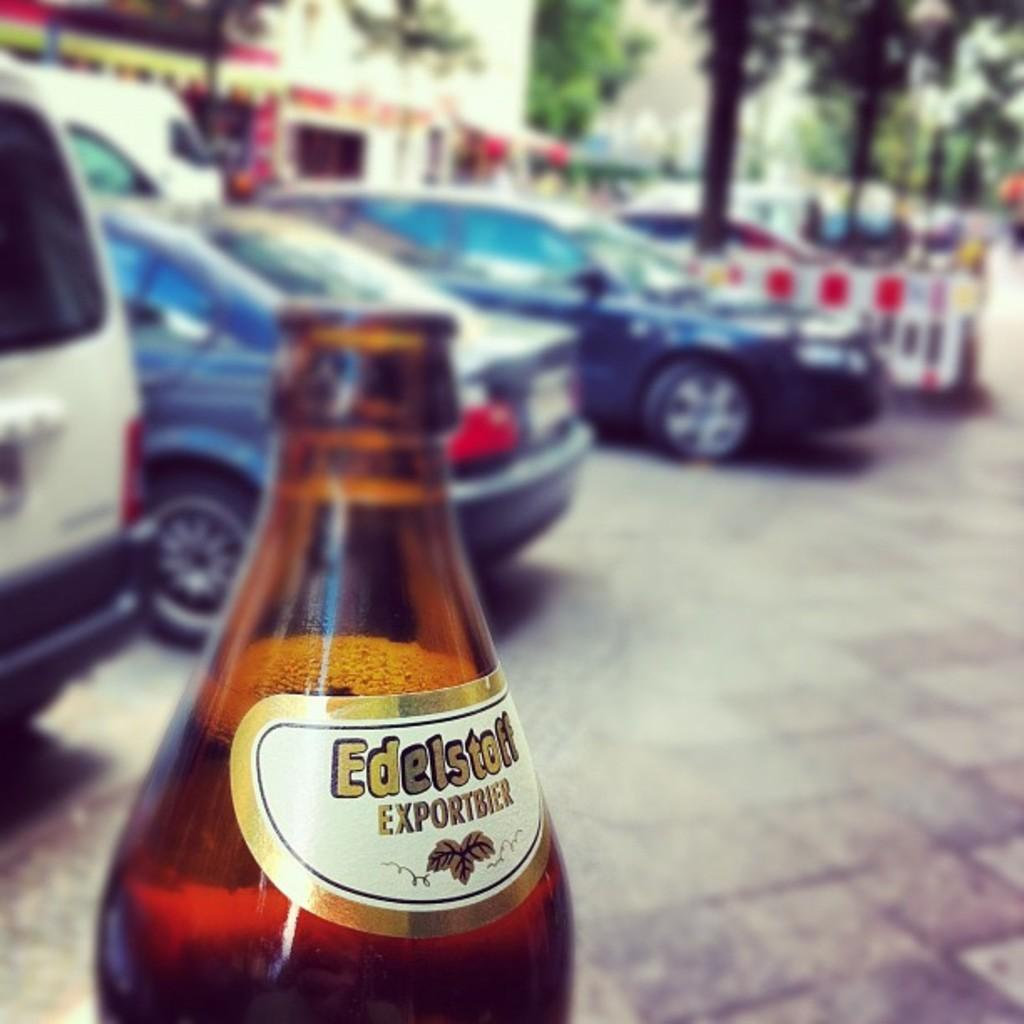What object is visible in the foreground of the image? There is a bottle in the image. What can be seen behind the bottle? There are cars behind the bottle. What is located behind the cars in the image? There are trees behind the cars. What type of structure is visible in the background of the image? There is a building in the background of the image. How many sheep are visible in the image? There are no sheep present in the image. What type of transportation is being used to support the building in the background? The image does not show any transportation being used to support the building; it only shows a bottle, cars, trees, and a building. 